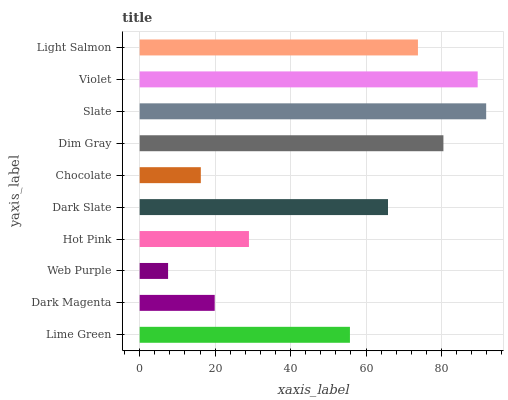Is Web Purple the minimum?
Answer yes or no. Yes. Is Slate the maximum?
Answer yes or no. Yes. Is Dark Magenta the minimum?
Answer yes or no. No. Is Dark Magenta the maximum?
Answer yes or no. No. Is Lime Green greater than Dark Magenta?
Answer yes or no. Yes. Is Dark Magenta less than Lime Green?
Answer yes or no. Yes. Is Dark Magenta greater than Lime Green?
Answer yes or no. No. Is Lime Green less than Dark Magenta?
Answer yes or no. No. Is Dark Slate the high median?
Answer yes or no. Yes. Is Lime Green the low median?
Answer yes or no. Yes. Is Web Purple the high median?
Answer yes or no. No. Is Web Purple the low median?
Answer yes or no. No. 